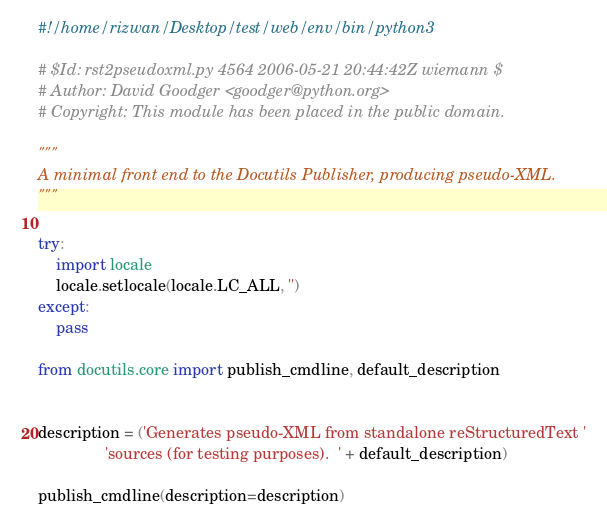Convert code to text. <code><loc_0><loc_0><loc_500><loc_500><_Python_>#!/home/rizwan/Desktop/test/web/env/bin/python3

# $Id: rst2pseudoxml.py 4564 2006-05-21 20:44:42Z wiemann $
# Author: David Goodger <goodger@python.org>
# Copyright: This module has been placed in the public domain.

"""
A minimal front end to the Docutils Publisher, producing pseudo-XML.
"""

try:
    import locale
    locale.setlocale(locale.LC_ALL, '')
except:
    pass

from docutils.core import publish_cmdline, default_description


description = ('Generates pseudo-XML from standalone reStructuredText '
               'sources (for testing purposes).  ' + default_description)

publish_cmdline(description=description)
</code> 